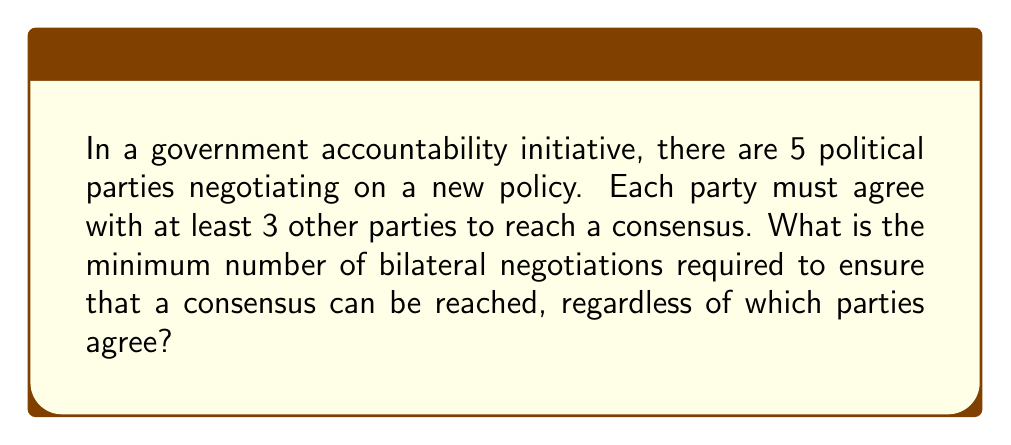Can you answer this question? Let's approach this step-by-step:

1) First, we need to understand what the question is asking. We're looking for the minimum number of bilateral negotiations (between two parties) that guarantees a consensus can be reached, no matter which parties end up agreeing.

2) In combinatorics, this is equivalent to finding the minimum number of edges in a graph with 5 vertices such that every vertex has at least 3 edges connected to it.

3) The total number of possible bilateral negotiations is $\binom{5}{2} = 10$, as there are $\frac{5!}{2!(5-2)!} = 10$ ways to choose 2 parties from 5.

4) To minimize the number of negotiations, we want to distribute the edges as evenly as possible. The ideal situation would be for each party to have exactly 3 connections.

5) However, this is impossible because:
   $$\frac{5 \times 3}{2} = 7.5$$
   The total number of edges must be an integer.

6) Therefore, some parties must have 4 connections. Let's say $x$ parties have 4 connections and $5-x$ have 3 connections.

7) The total number of edges would be:
   $$\frac{4x + 3(5-x)}{2} = \frac{4x + 15 - 3x}{2} = \frac{x + 15}{2}$$

8) For this to be an integer, $x$ must be odd. The smallest odd number greater than 0 is 1.

9) So, the minimum configuration is 1 party with 4 connections and 4 parties with 3 connections.

10) This gives us a total of:
    $$\frac{1 \times 4 + 4 \times 3}{2} = \frac{4 + 12}{2} = 8$$ bilateral negotiations.

Therefore, the minimum number of bilateral negotiations required is 8.
Answer: 8 